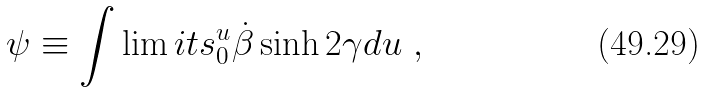<formula> <loc_0><loc_0><loc_500><loc_500>\psi \equiv \int \lim i t s _ { 0 } ^ { u } \dot { \beta } \sinh 2 \gamma d u \ ,</formula> 